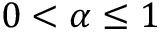Convert formula to latex. <formula><loc_0><loc_0><loc_500><loc_500>0 < \alpha \leq 1</formula> 